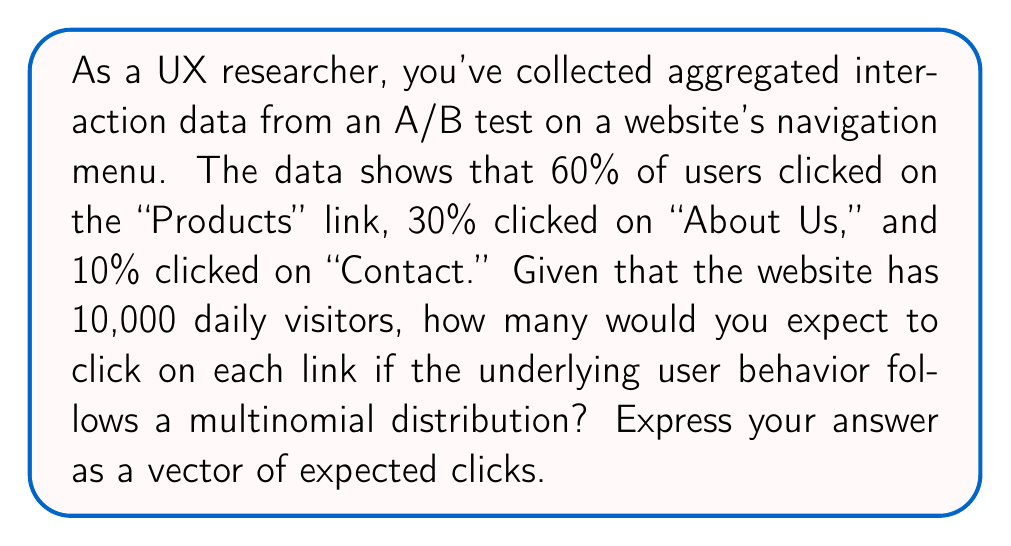Solve this math problem. To solve this problem, we need to use the properties of the multinomial distribution and apply them to our aggregated data. Here's a step-by-step approach:

1. Identify the parameters of the multinomial distribution:
   - $n$ = total number of trials (daily visitors) = 10,000
   - $p_1$ = probability of clicking "Products" = 0.60
   - $p_2$ = probability of clicking "About Us" = 0.30
   - $p_3$ = probability of clicking "Contact" = 0.10

2. Calculate the expected value for each category:
   The expected value for each category in a multinomial distribution is given by:
   $E(X_i) = n \cdot p_i$

   For "Products":
   $E(X_1) = 10,000 \cdot 0.60 = 6,000$

   For "About Us":
   $E(X_2) = 10,000 \cdot 0.30 = 3,000$

   For "Contact":
   $E(X_3) = 10,000 \cdot 0.10 = 1,000$

3. Express the result as a vector of expected clicks:
   $\mathbf{E(X)} = (E(X_1), E(X_2), E(X_3)) = (6000, 3000, 1000)$

This vector represents the expected number of clicks for each link based on the underlying user behavior model inferred from the aggregated interaction data.
Answer: $(6000, 3000, 1000)$ 